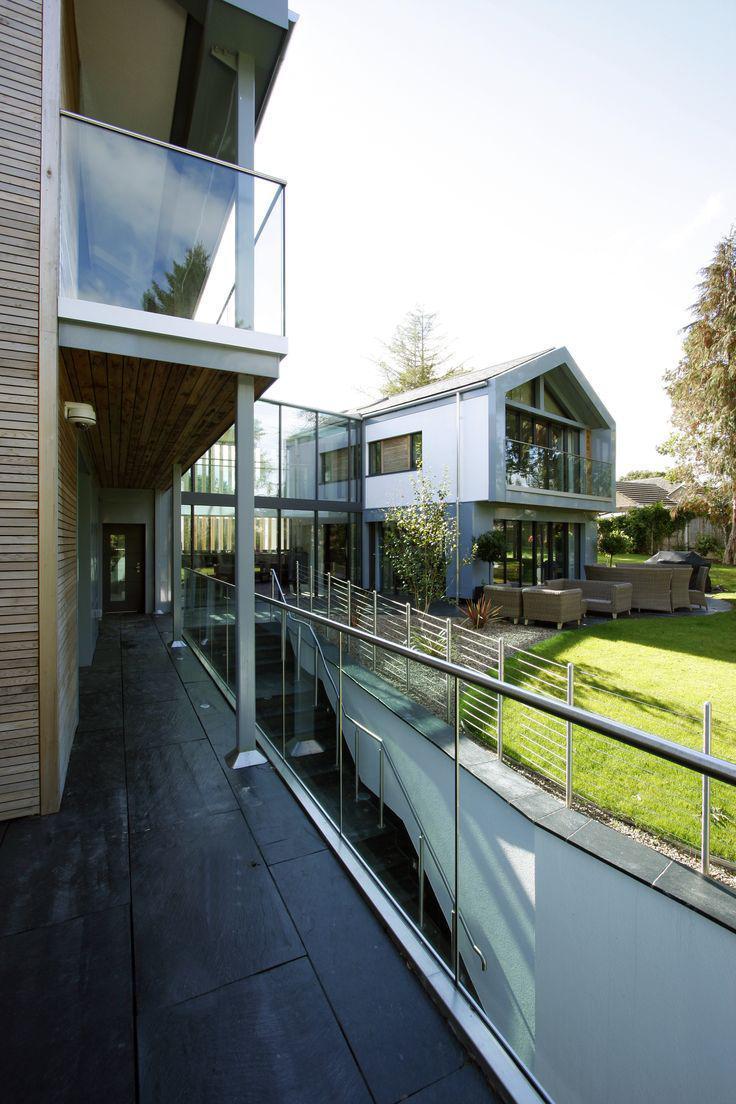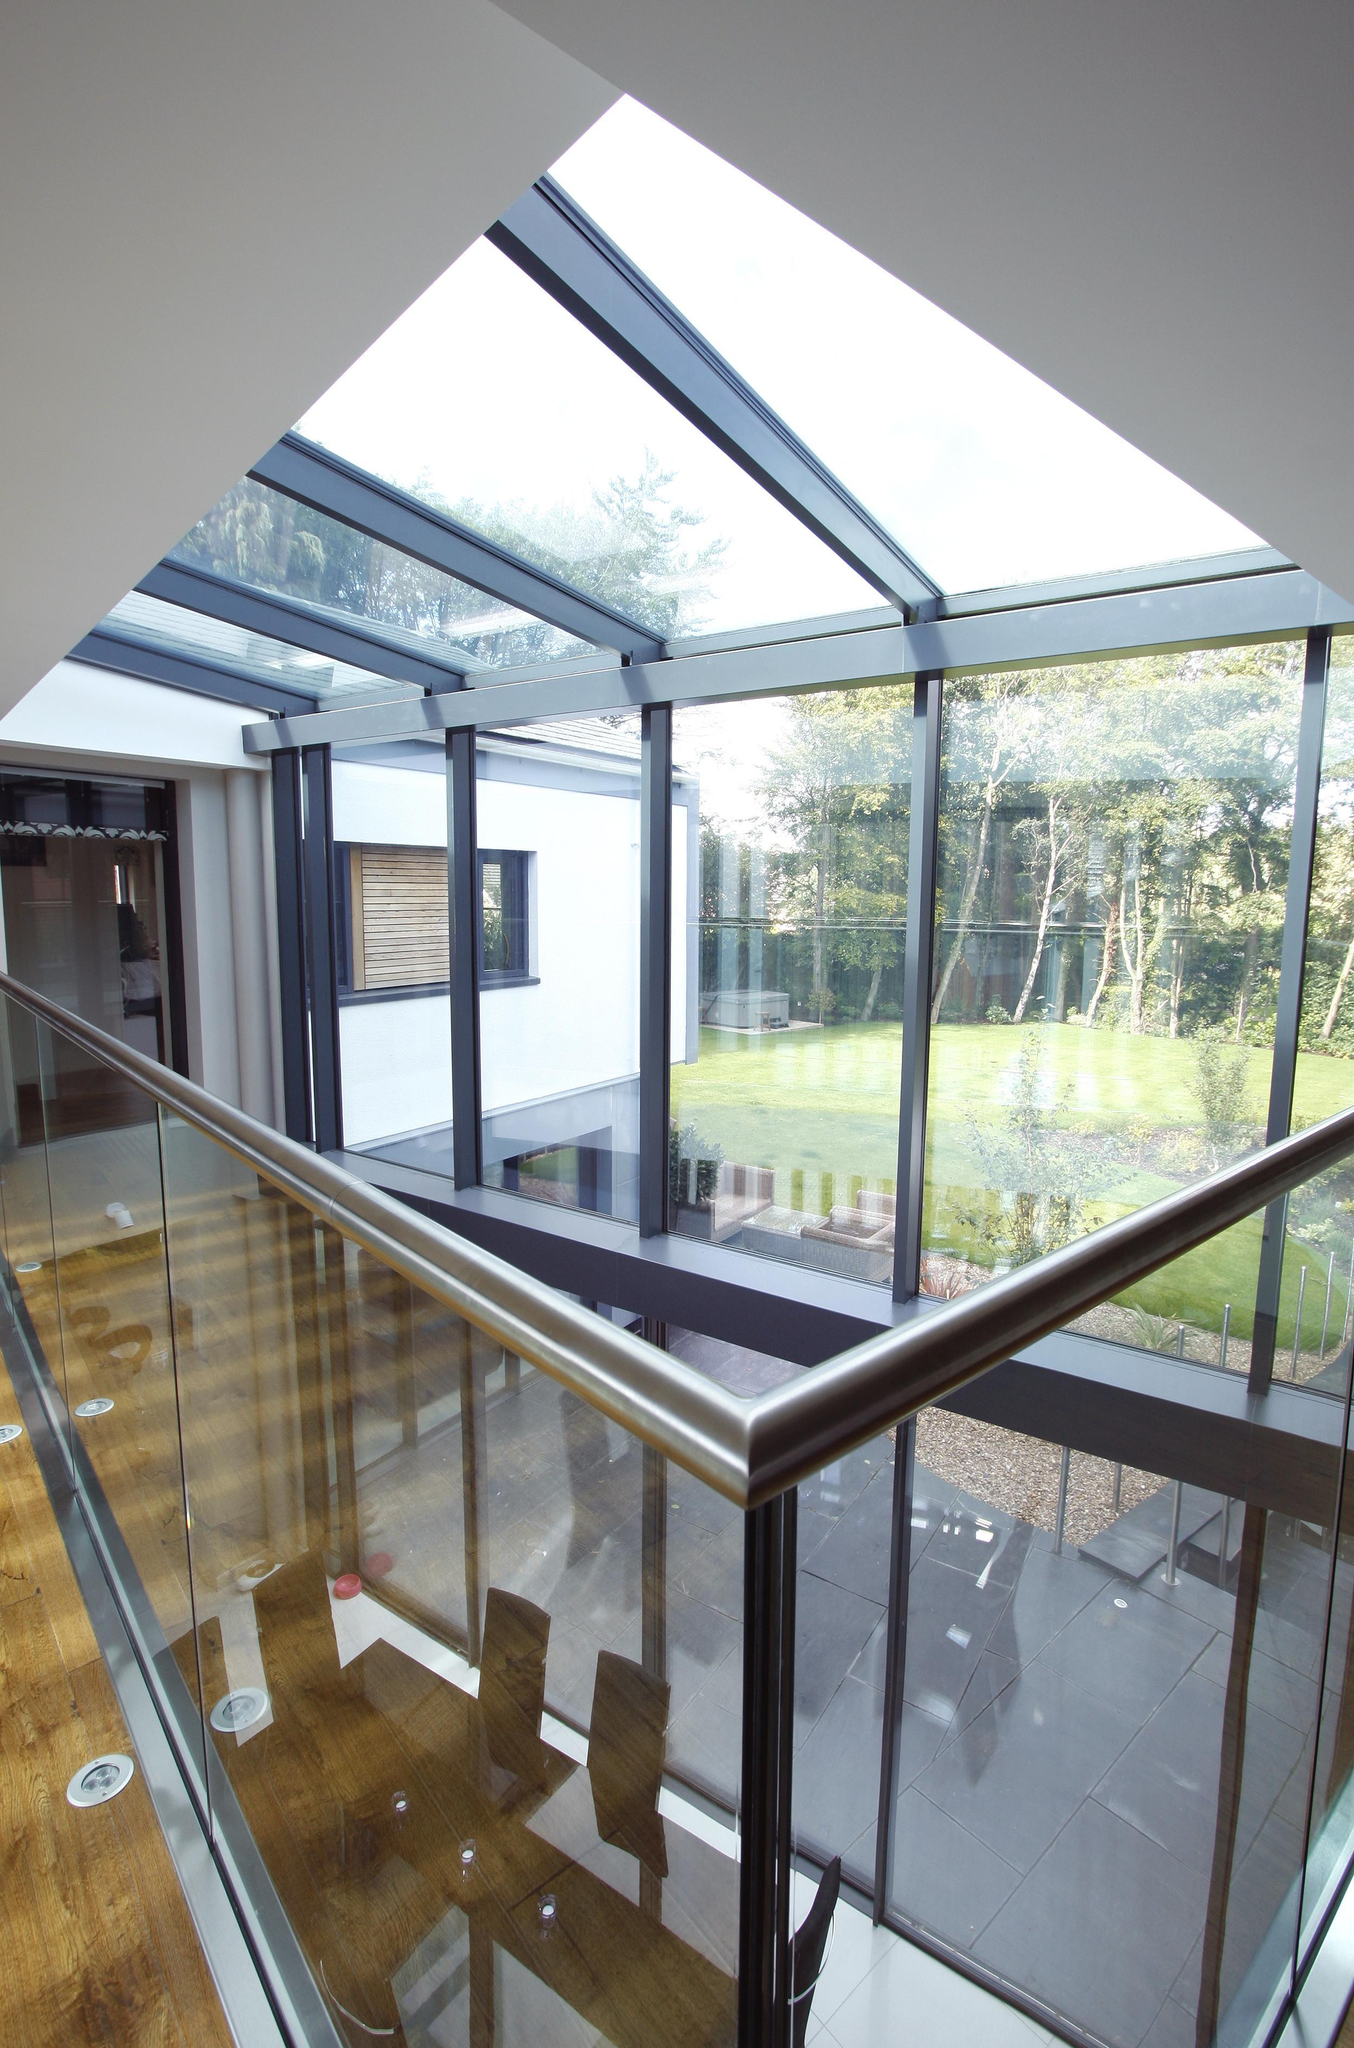The first image is the image on the left, the second image is the image on the right. For the images shown, is this caption "Each image features a glass-paneled balcony alongside a deck with plank boards, overlooking similar scenery." true? Answer yes or no. No. The first image is the image on the left, the second image is the image on the right. Examine the images to the left and right. Is the description "Both images are outside." accurate? Answer yes or no. No. 